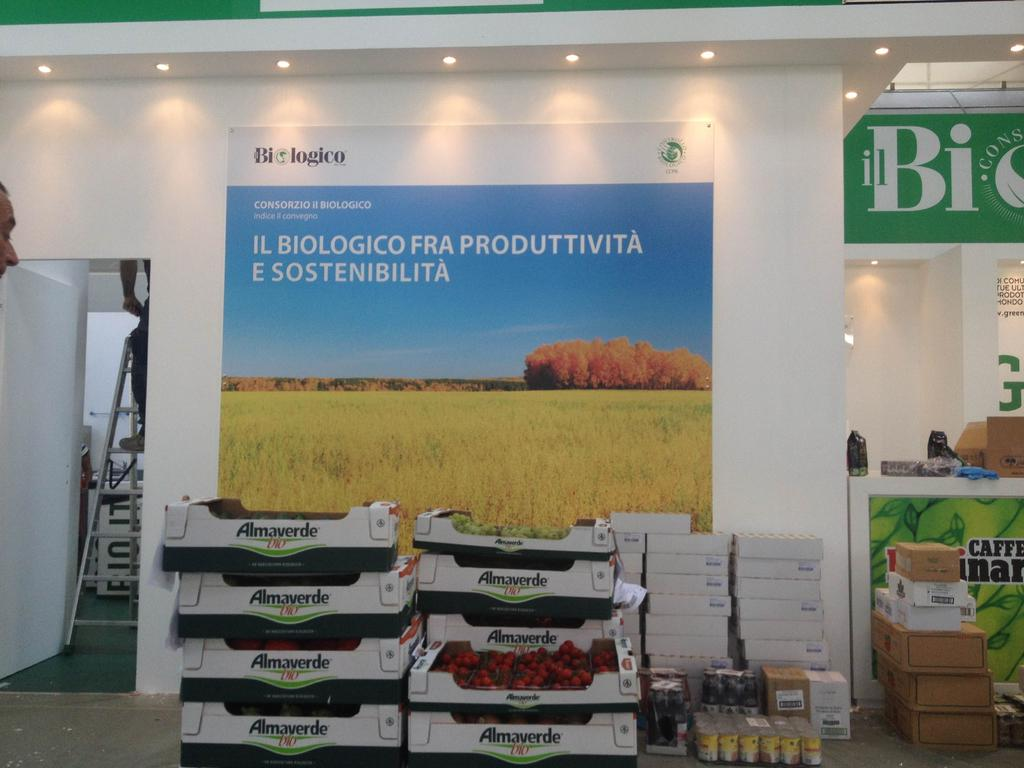What is attached to the wall in the image? There is a poster board on the wall in the image. Can you describe what is visible behind the poster board? There are other objects or elements visible behind the poster board. What language is being spoken by the objects behind the poster board in the image? There is no indication of any language being spoken by the objects behind the poster board in the image, as objects do not speak. 